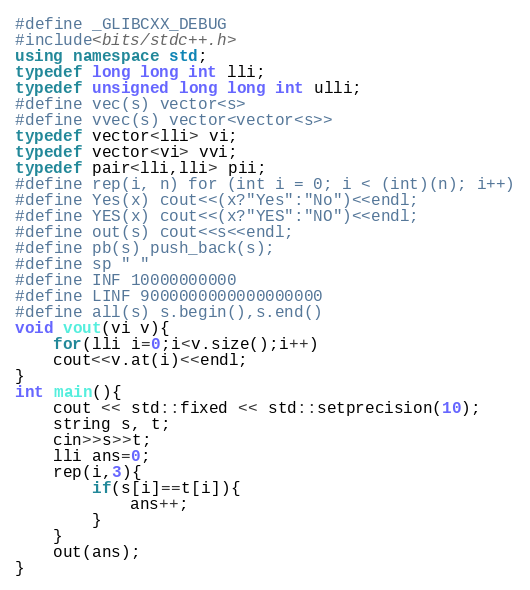Convert code to text. <code><loc_0><loc_0><loc_500><loc_500><_C++_>#define _GLIBCXX_DEBUG
#include<bits/stdc++.h>
using namespace std;
typedef long long int lli;
typedef unsigned long long int ulli;
#define vec(s) vector<s>
#define vvec(s) vector<vector<s>>
typedef vector<lli> vi;
typedef vector<vi> vvi;
typedef pair<lli,lli> pii;
#define rep(i, n) for (int i = 0; i < (int)(n); i++)
#define Yes(x) cout<<(x?"Yes":"No")<<endl;
#define YES(x) cout<<(x?"YES":"NO")<<endl;
#define out(s) cout<<s<<endl;
#define pb(s) push_back(s);
#define sp " " 
#define INF 10000000000
#define LINF 9000000000000000000
#define all(s) s.begin(),s.end()
void vout(vi v){
    for(lli i=0;i<v.size();i++)
    cout<<v.at(i)<<endl;
}
int main(){
    cout << std::fixed << std::setprecision(10);
    string s, t;
    cin>>s>>t;
    lli ans=0;
    rep(i,3){
        if(s[i]==t[i]){ 
            ans++;
        }
    }
    out(ans);
}
</code> 